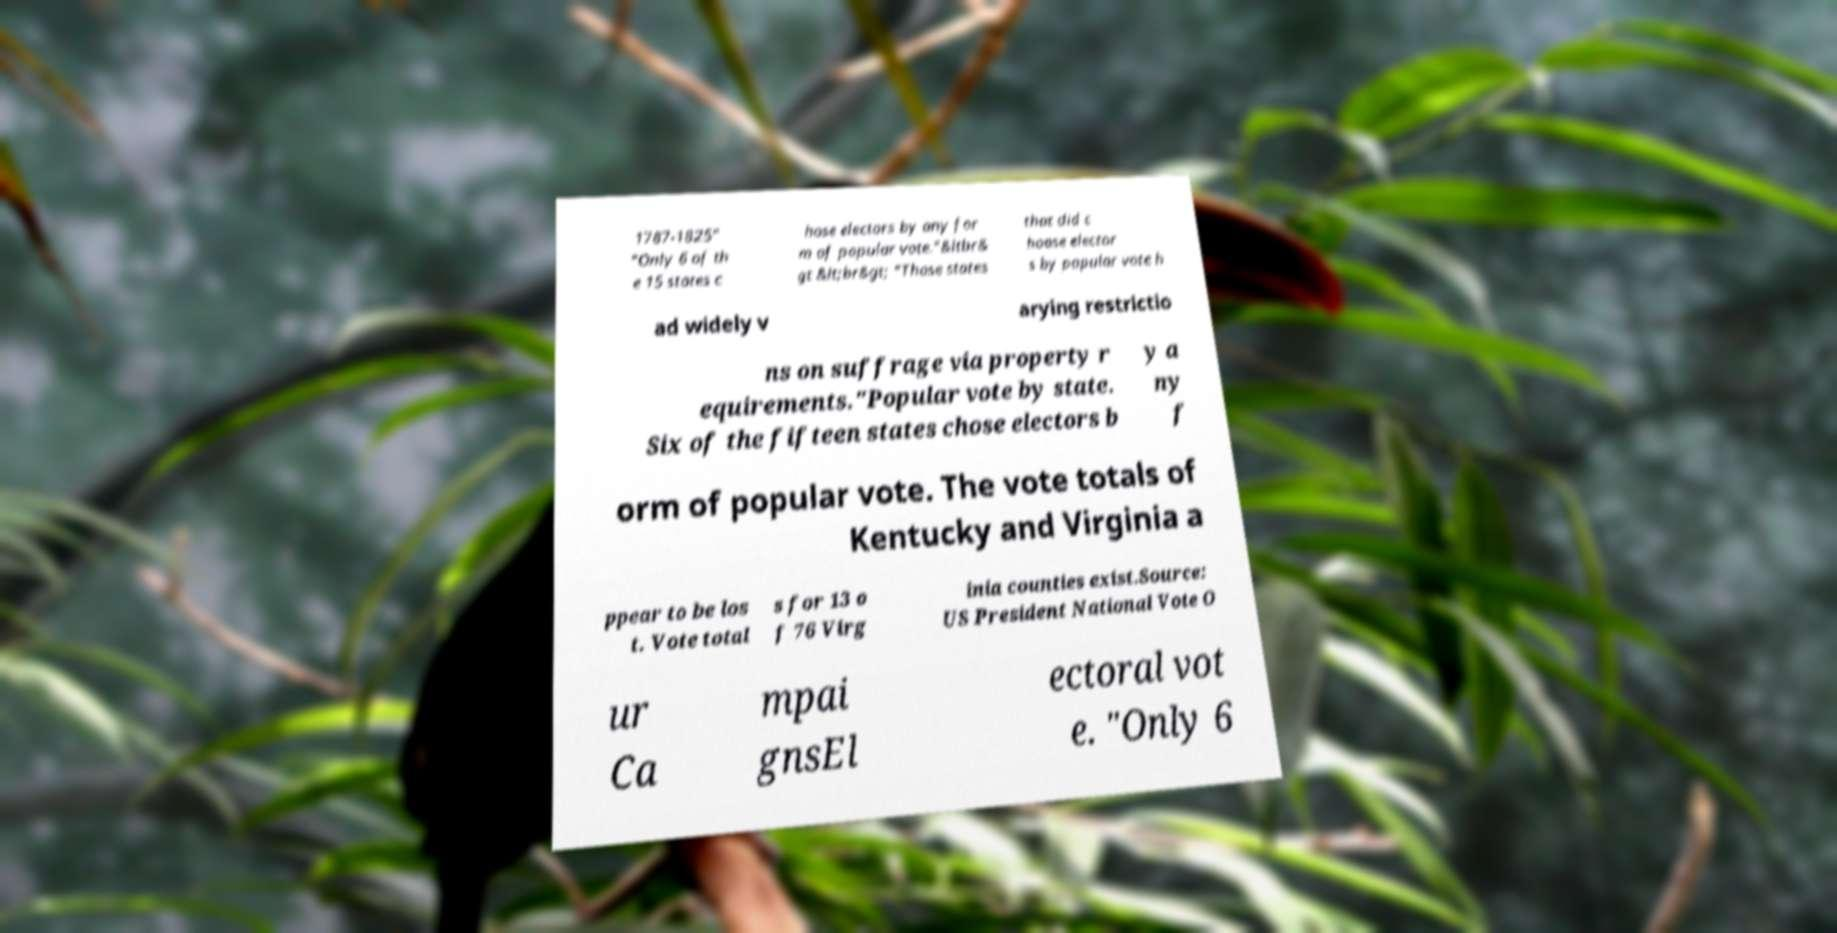There's text embedded in this image that I need extracted. Can you transcribe it verbatim? 1787-1825" "Only 6 of th e 15 states c hose electors by any for m of popular vote."&ltbr& gt &lt;br&gt; "Those states that did c hoose elector s by popular vote h ad widely v arying restrictio ns on suffrage via property r equirements."Popular vote by state. Six of the fifteen states chose electors b y a ny f orm of popular vote. The vote totals of Kentucky and Virginia a ppear to be los t. Vote total s for 13 o f 76 Virg inia counties exist.Source: US President National Vote O ur Ca mpai gnsEl ectoral vot e. "Only 6 